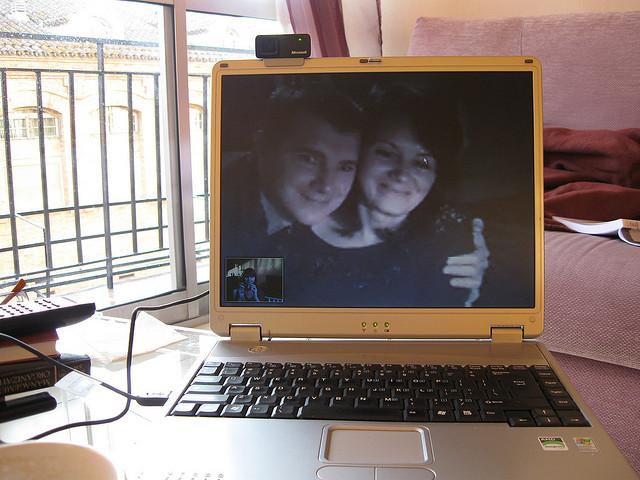Is the computer turned on?
Give a very brief answer. Yes. How many people are shown on the computer?
Answer briefly. 2. Is the webcam built into the computer?
Concise answer only. No. 